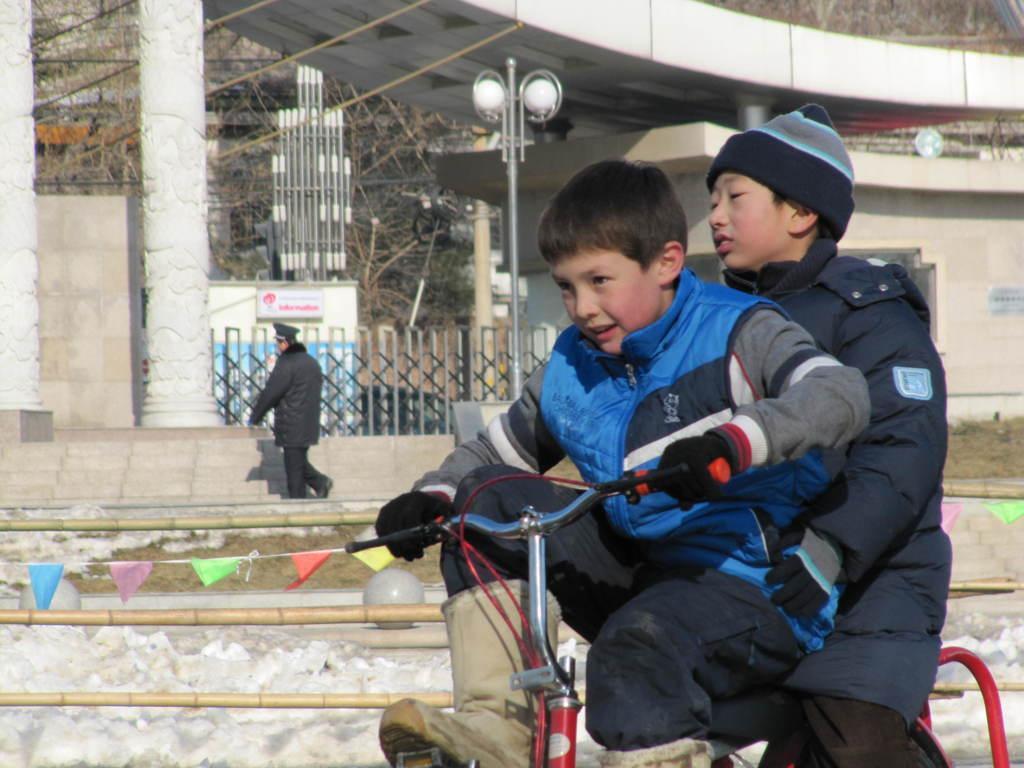In one or two sentences, can you explain what this image depicts? In front of the picture, we see a boy in blue jacket is cycling. Behind him, we see a boy is riding the bicycle. Beside them, we see the wooden fence and the flags in blue, purple, green, red and yellow color. In the middle of the picture, we see a man is walking. In front of him, we see the staircase and behind him, we see the light poles. There are pillars, iron railing, bridge and a wall in the background. In the background, we see the trees and the electric transformer. 